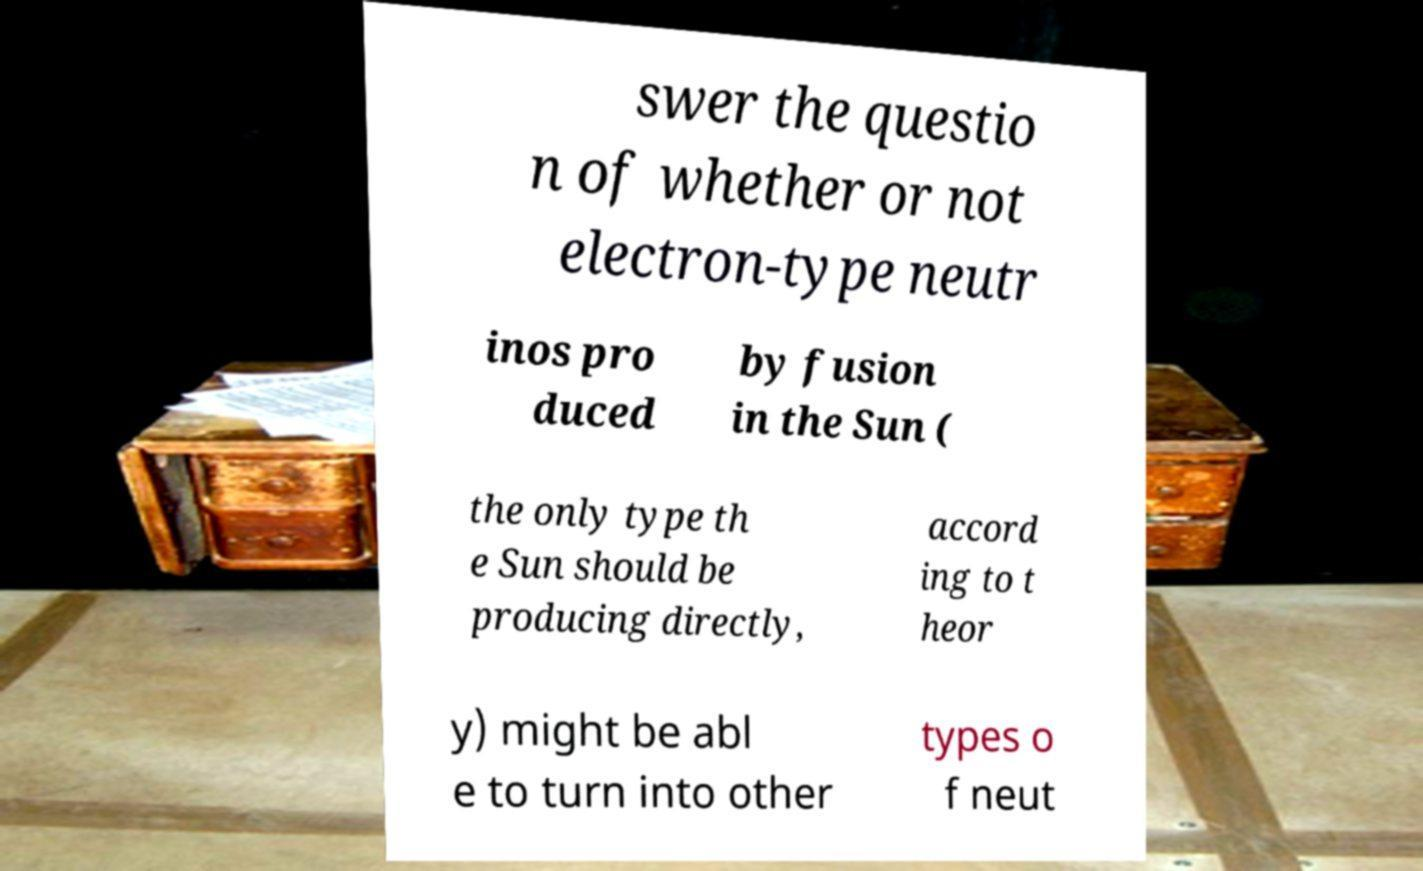Can you accurately transcribe the text from the provided image for me? swer the questio n of whether or not electron-type neutr inos pro duced by fusion in the Sun ( the only type th e Sun should be producing directly, accord ing to t heor y) might be abl e to turn into other types o f neut 